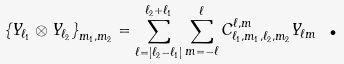Convert formula to latex. <formula><loc_0><loc_0><loc_500><loc_500>\left \{ Y _ { \ell _ { 1 } } \otimes Y _ { \ell _ { 2 } } \right \} _ { m _ { 1 } , m _ { 2 } } = \sum _ { \ell = | \ell _ { 2 } - \ell _ { 1 } | } ^ { \ell _ { 2 } + \ell _ { 1 } } \sum _ { m = - \ell } ^ { \ell } C _ { \ell _ { 1 } , m _ { 1 } , \ell _ { 2 } , m _ { 2 } } ^ { \ell , m } Y _ { \ell m } \text { .}</formula> 